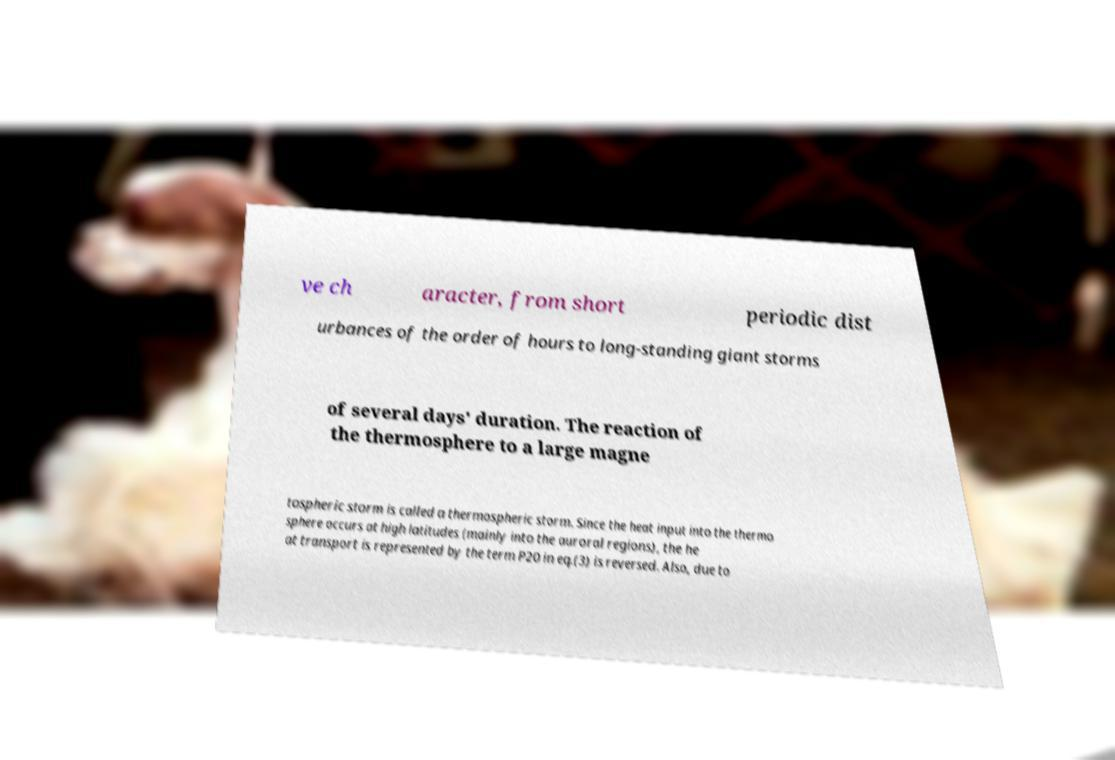Can you accurately transcribe the text from the provided image for me? ve ch aracter, from short periodic dist urbances of the order of hours to long-standing giant storms of several days' duration. The reaction of the thermosphere to a large magne tospheric storm is called a thermospheric storm. Since the heat input into the thermo sphere occurs at high latitudes (mainly into the auroral regions), the he at transport is represented by the term P20 in eq.(3) is reversed. Also, due to 